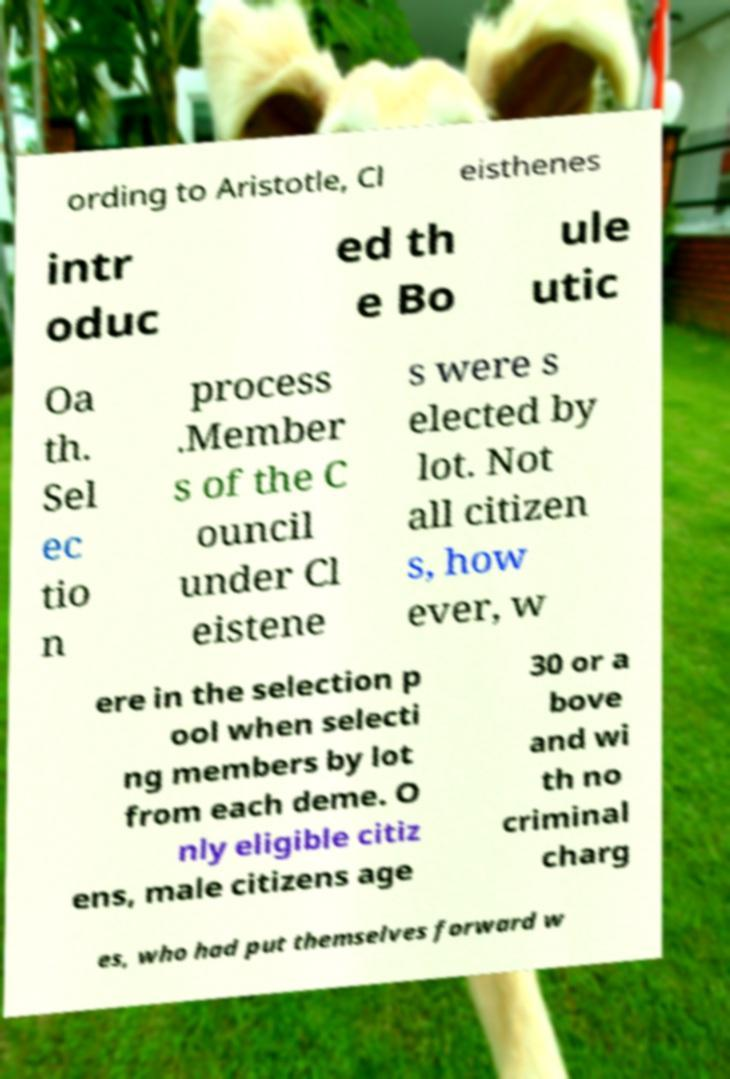Could you assist in decoding the text presented in this image and type it out clearly? ording to Aristotle, Cl eisthenes intr oduc ed th e Bo ule utic Oa th. Sel ec tio n process .Member s of the C ouncil under Cl eistene s were s elected by lot. Not all citizen s, how ever, w ere in the selection p ool when selecti ng members by lot from each deme. O nly eligible citiz ens, male citizens age 30 or a bove and wi th no criminal charg es, who had put themselves forward w 